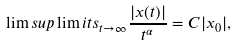<formula> <loc_0><loc_0><loc_500><loc_500>\lim s u p \lim i t s _ { t \rightarrow \infty } \frac { | x ( t ) | } { t ^ { \alpha } } = C | x _ { 0 } | ,</formula> 